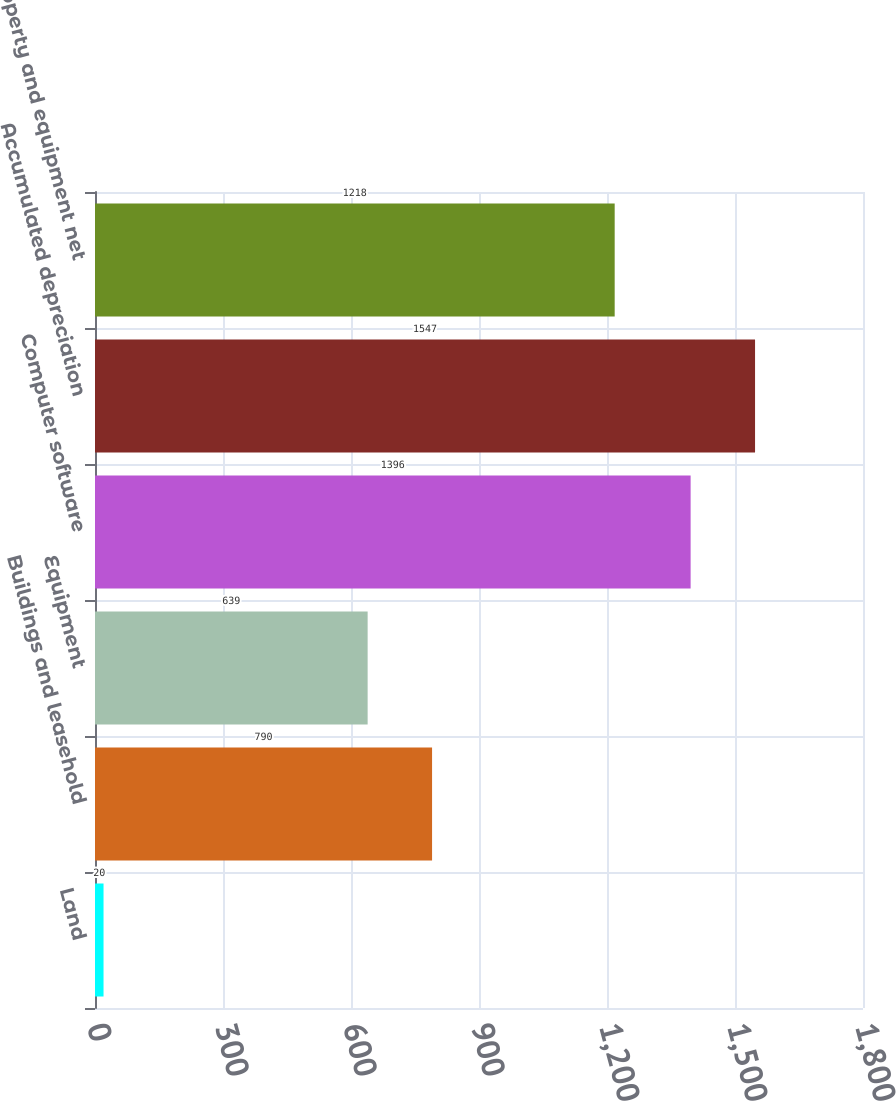Convert chart. <chart><loc_0><loc_0><loc_500><loc_500><bar_chart><fcel>Land<fcel>Buildings and leasehold<fcel>Equipment<fcel>Computer software<fcel>Accumulated depreciation<fcel>Property and equipment net<nl><fcel>20<fcel>790<fcel>639<fcel>1396<fcel>1547<fcel>1218<nl></chart> 